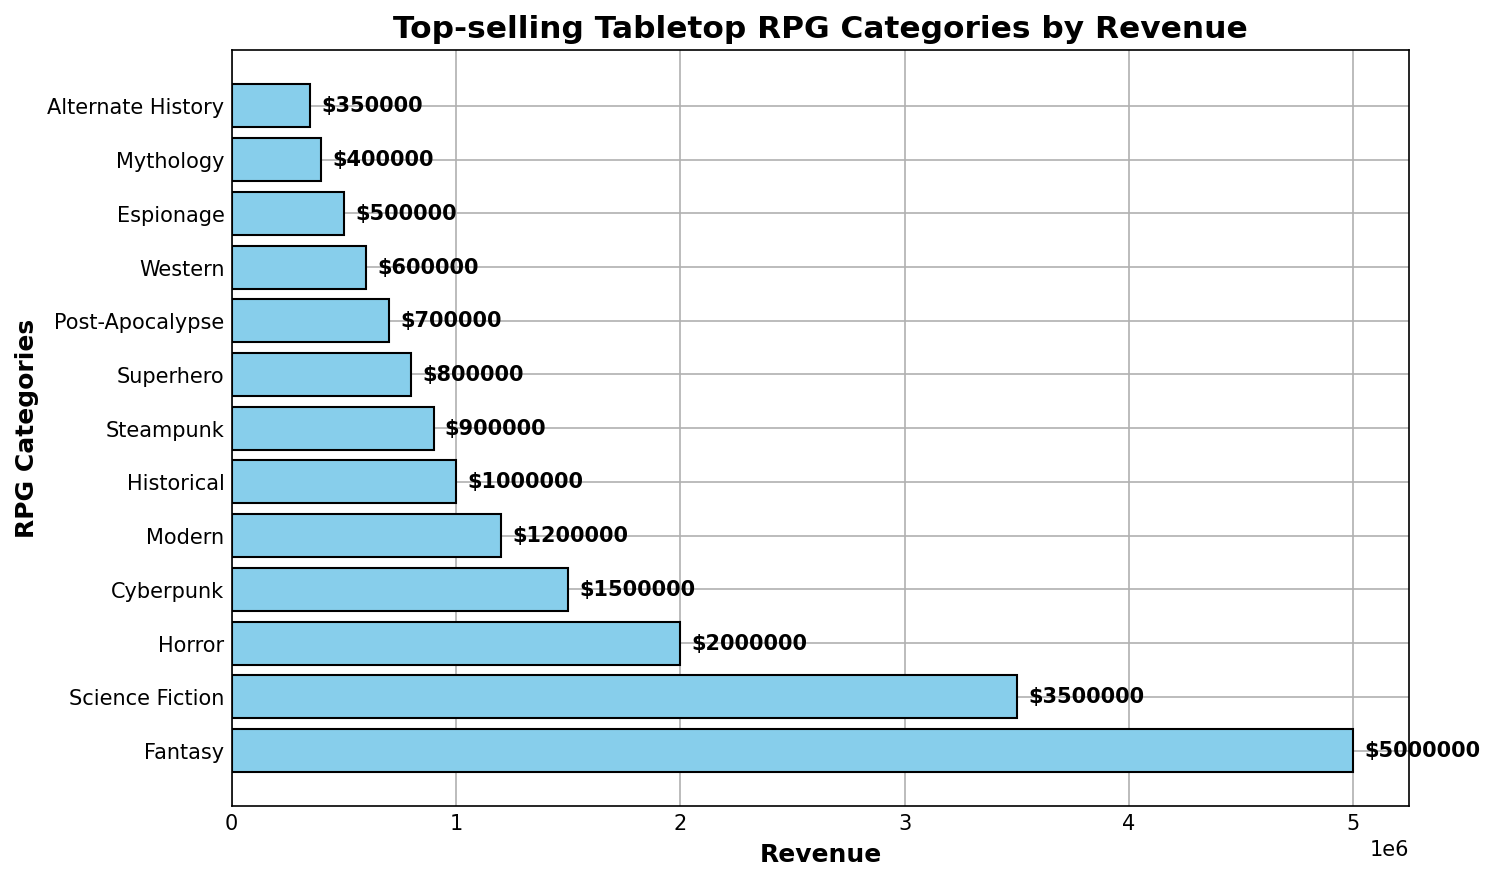What's the highest revenue category? To identify this, look at the bar with the greatest length. The "Fantasy" bar is the longest, corresponding to $5,000,000 in revenue.
Answer: Fantasy Which category has the lowest revenue? Look for the shortest bar in the chart. The "Alternate History" bar is the shortest, corresponding to $350,000.
Answer: Alternate History How much more revenue does Science Fiction generate compared to Steampunk? Examine the lengths of the bars for both "Science Fiction" and "Steampunk." Science Fiction generates $3,500,000 and Steampunk generates $900,000. The difference is $3,500,000 - $900,000 = $2,600,000.
Answer: $2,600,000 What's the total revenue generated by the top three categories? Identify the top three categories by bar length: Fantasy ($5,000,000), Science Fiction ($3,500,000), and Horror ($2,000,000). Sum these values: $5,000,000 + $3,500,000 + $2,000,000 = $10,500,000.
Answer: $10,500,000 Which categories generate more than $2,000,000 in revenue? Look for bars that extend beyond the $2,000,000 mark. These categories are Fantasy ($5,000,000) and Science Fiction ($3,500,000).
Answer: Fantasy, Science Fiction What’s the average revenue of all presented RPG categories? Sum the revenues of all categories and divide by the number of categories. The total revenue is $17,212,000 and there are 13 categories. So, the average is $17,212,000 / 13 = approximately $1,324,769.23.
Answer: ~$1,324,769.23 How much revenue do Cyberpunk and Modern categories generate together? Add the revenues for Cyberpunk ($1,500,000) and Modern ($1,200,000): $1,500,000 + $1,200,000 = $2,700,000.
Answer: $2,700,000 Is the revenue of Superhero greater than the combined revenue of Mythology and Western? Superhero generates $800,000. Mythology is $400,000 and Western is $600,000. Combined, Mythology and Western generate $1,000,000. Since $800,000 is less than $1,000,000, Superhero does not generate more revenue.
Answer: No Which category ranks fourth in revenue generation? Rank the categories by the bar lengths. The fourth longest bar after Fantasy, Science Fiction, and Horror is Cyberpunk at $1,500,000.
Answer: Cyberpunk 